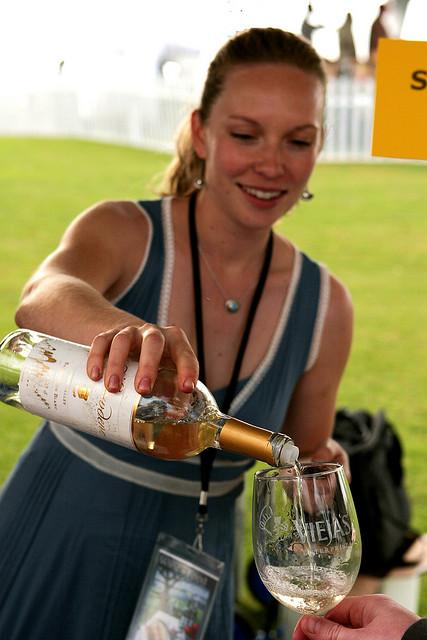Is the woman pouring wine?
Write a very short answer. Yes. What color dress is the woman wearing?
Quick response, please. Blue. What is in the woman's glass?
Keep it brief. Wine. 